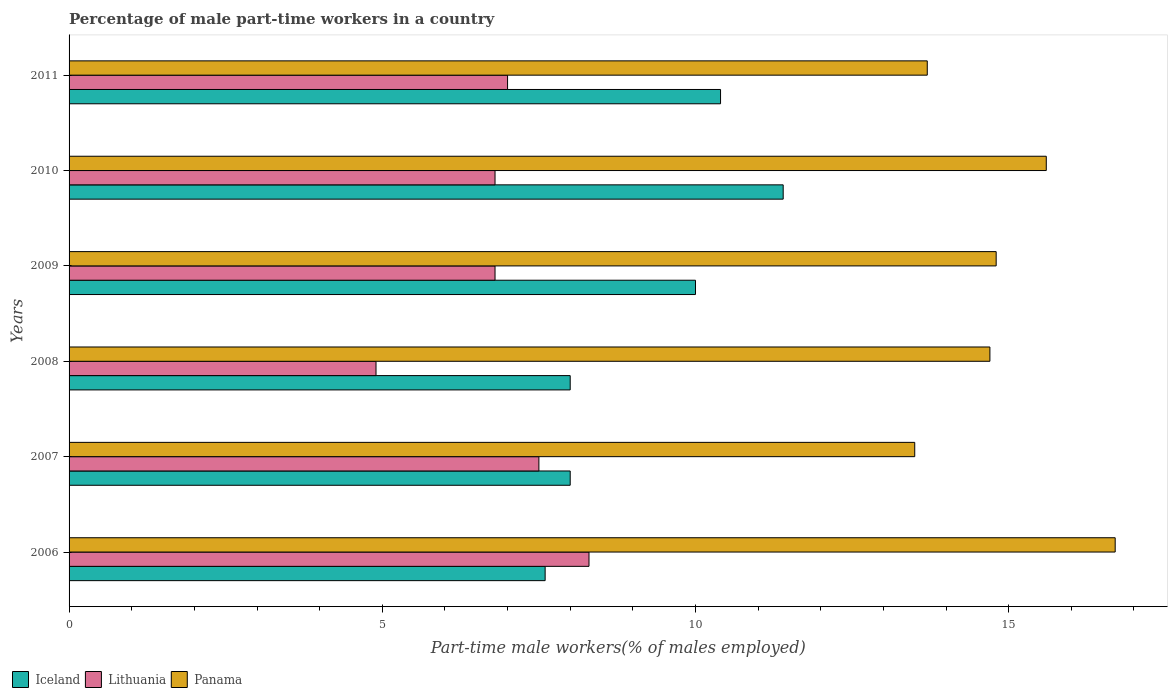How many different coloured bars are there?
Offer a terse response. 3. Are the number of bars on each tick of the Y-axis equal?
Provide a short and direct response. Yes. How many bars are there on the 1st tick from the bottom?
Offer a terse response. 3. What is the label of the 3rd group of bars from the top?
Provide a succinct answer. 2009. What is the percentage of male part-time workers in Iceland in 2006?
Your response must be concise. 7.6. Across all years, what is the maximum percentage of male part-time workers in Panama?
Make the answer very short. 16.7. Across all years, what is the minimum percentage of male part-time workers in Lithuania?
Offer a very short reply. 4.9. In which year was the percentage of male part-time workers in Iceland maximum?
Offer a terse response. 2010. What is the total percentage of male part-time workers in Lithuania in the graph?
Make the answer very short. 41.3. What is the difference between the percentage of male part-time workers in Lithuania in 2007 and that in 2008?
Provide a succinct answer. 2.6. What is the difference between the percentage of male part-time workers in Lithuania in 2006 and the percentage of male part-time workers in Panama in 2007?
Give a very brief answer. -5.2. What is the average percentage of male part-time workers in Lithuania per year?
Your response must be concise. 6.88. In the year 2010, what is the difference between the percentage of male part-time workers in Panama and percentage of male part-time workers in Lithuania?
Make the answer very short. 8.8. In how many years, is the percentage of male part-time workers in Panama greater than 6 %?
Ensure brevity in your answer.  6. What is the ratio of the percentage of male part-time workers in Iceland in 2006 to that in 2007?
Offer a terse response. 0.95. Is the difference between the percentage of male part-time workers in Panama in 2009 and 2011 greater than the difference between the percentage of male part-time workers in Lithuania in 2009 and 2011?
Your response must be concise. Yes. What is the difference between the highest and the lowest percentage of male part-time workers in Panama?
Ensure brevity in your answer.  3.2. In how many years, is the percentage of male part-time workers in Lithuania greater than the average percentage of male part-time workers in Lithuania taken over all years?
Provide a short and direct response. 3. What does the 3rd bar from the top in 2009 represents?
Provide a short and direct response. Iceland. Is it the case that in every year, the sum of the percentage of male part-time workers in Panama and percentage of male part-time workers in Iceland is greater than the percentage of male part-time workers in Lithuania?
Keep it short and to the point. Yes. How many bars are there?
Offer a very short reply. 18. Are all the bars in the graph horizontal?
Keep it short and to the point. Yes. Does the graph contain grids?
Provide a short and direct response. No. How are the legend labels stacked?
Offer a terse response. Horizontal. What is the title of the graph?
Provide a succinct answer. Percentage of male part-time workers in a country. What is the label or title of the X-axis?
Give a very brief answer. Part-time male workers(% of males employed). What is the Part-time male workers(% of males employed) in Iceland in 2006?
Give a very brief answer. 7.6. What is the Part-time male workers(% of males employed) in Lithuania in 2006?
Ensure brevity in your answer.  8.3. What is the Part-time male workers(% of males employed) of Panama in 2006?
Provide a short and direct response. 16.7. What is the Part-time male workers(% of males employed) of Lithuania in 2008?
Offer a terse response. 4.9. What is the Part-time male workers(% of males employed) in Panama in 2008?
Give a very brief answer. 14.7. What is the Part-time male workers(% of males employed) in Iceland in 2009?
Make the answer very short. 10. What is the Part-time male workers(% of males employed) of Lithuania in 2009?
Your response must be concise. 6.8. What is the Part-time male workers(% of males employed) in Panama in 2009?
Ensure brevity in your answer.  14.8. What is the Part-time male workers(% of males employed) in Iceland in 2010?
Provide a short and direct response. 11.4. What is the Part-time male workers(% of males employed) in Lithuania in 2010?
Give a very brief answer. 6.8. What is the Part-time male workers(% of males employed) in Panama in 2010?
Provide a succinct answer. 15.6. What is the Part-time male workers(% of males employed) of Iceland in 2011?
Make the answer very short. 10.4. What is the Part-time male workers(% of males employed) of Panama in 2011?
Your answer should be very brief. 13.7. Across all years, what is the maximum Part-time male workers(% of males employed) in Iceland?
Your response must be concise. 11.4. Across all years, what is the maximum Part-time male workers(% of males employed) in Lithuania?
Your answer should be very brief. 8.3. Across all years, what is the maximum Part-time male workers(% of males employed) in Panama?
Keep it short and to the point. 16.7. Across all years, what is the minimum Part-time male workers(% of males employed) of Iceland?
Your response must be concise. 7.6. Across all years, what is the minimum Part-time male workers(% of males employed) in Lithuania?
Your answer should be very brief. 4.9. Across all years, what is the minimum Part-time male workers(% of males employed) of Panama?
Ensure brevity in your answer.  13.5. What is the total Part-time male workers(% of males employed) of Iceland in the graph?
Your answer should be very brief. 55.4. What is the total Part-time male workers(% of males employed) of Lithuania in the graph?
Your answer should be compact. 41.3. What is the total Part-time male workers(% of males employed) of Panama in the graph?
Ensure brevity in your answer.  89. What is the difference between the Part-time male workers(% of males employed) in Iceland in 2006 and that in 2007?
Make the answer very short. -0.4. What is the difference between the Part-time male workers(% of males employed) in Panama in 2006 and that in 2007?
Offer a terse response. 3.2. What is the difference between the Part-time male workers(% of males employed) of Iceland in 2006 and that in 2008?
Provide a succinct answer. -0.4. What is the difference between the Part-time male workers(% of males employed) in Lithuania in 2006 and that in 2008?
Give a very brief answer. 3.4. What is the difference between the Part-time male workers(% of males employed) in Panama in 2006 and that in 2008?
Provide a succinct answer. 2. What is the difference between the Part-time male workers(% of males employed) in Iceland in 2006 and that in 2009?
Your response must be concise. -2.4. What is the difference between the Part-time male workers(% of males employed) of Iceland in 2006 and that in 2010?
Your answer should be very brief. -3.8. What is the difference between the Part-time male workers(% of males employed) of Lithuania in 2006 and that in 2010?
Provide a succinct answer. 1.5. What is the difference between the Part-time male workers(% of males employed) in Lithuania in 2006 and that in 2011?
Make the answer very short. 1.3. What is the difference between the Part-time male workers(% of males employed) of Panama in 2006 and that in 2011?
Your answer should be compact. 3. What is the difference between the Part-time male workers(% of males employed) of Iceland in 2007 and that in 2008?
Provide a short and direct response. 0. What is the difference between the Part-time male workers(% of males employed) in Panama in 2007 and that in 2008?
Give a very brief answer. -1.2. What is the difference between the Part-time male workers(% of males employed) of Lithuania in 2007 and that in 2009?
Ensure brevity in your answer.  0.7. What is the difference between the Part-time male workers(% of males employed) of Iceland in 2007 and that in 2010?
Give a very brief answer. -3.4. What is the difference between the Part-time male workers(% of males employed) of Iceland in 2007 and that in 2011?
Your answer should be compact. -2.4. What is the difference between the Part-time male workers(% of males employed) of Lithuania in 2007 and that in 2011?
Offer a very short reply. 0.5. What is the difference between the Part-time male workers(% of males employed) of Lithuania in 2008 and that in 2011?
Give a very brief answer. -2.1. What is the difference between the Part-time male workers(% of males employed) of Iceland in 2009 and that in 2010?
Your response must be concise. -1.4. What is the difference between the Part-time male workers(% of males employed) of Panama in 2009 and that in 2010?
Provide a succinct answer. -0.8. What is the difference between the Part-time male workers(% of males employed) of Iceland in 2009 and that in 2011?
Keep it short and to the point. -0.4. What is the difference between the Part-time male workers(% of males employed) in Iceland in 2010 and that in 2011?
Make the answer very short. 1. What is the difference between the Part-time male workers(% of males employed) of Panama in 2010 and that in 2011?
Ensure brevity in your answer.  1.9. What is the difference between the Part-time male workers(% of males employed) of Iceland in 2006 and the Part-time male workers(% of males employed) of Panama in 2007?
Give a very brief answer. -5.9. What is the difference between the Part-time male workers(% of males employed) in Lithuania in 2006 and the Part-time male workers(% of males employed) in Panama in 2007?
Offer a terse response. -5.2. What is the difference between the Part-time male workers(% of males employed) of Iceland in 2006 and the Part-time male workers(% of males employed) of Panama in 2008?
Ensure brevity in your answer.  -7.1. What is the difference between the Part-time male workers(% of males employed) of Lithuania in 2006 and the Part-time male workers(% of males employed) of Panama in 2008?
Provide a succinct answer. -6.4. What is the difference between the Part-time male workers(% of males employed) in Iceland in 2006 and the Part-time male workers(% of males employed) in Panama in 2009?
Your answer should be compact. -7.2. What is the difference between the Part-time male workers(% of males employed) in Lithuania in 2006 and the Part-time male workers(% of males employed) in Panama in 2009?
Give a very brief answer. -6.5. What is the difference between the Part-time male workers(% of males employed) in Iceland in 2006 and the Part-time male workers(% of males employed) in Panama in 2010?
Give a very brief answer. -8. What is the difference between the Part-time male workers(% of males employed) of Iceland in 2007 and the Part-time male workers(% of males employed) of Lithuania in 2008?
Your answer should be very brief. 3.1. What is the difference between the Part-time male workers(% of males employed) of Lithuania in 2007 and the Part-time male workers(% of males employed) of Panama in 2008?
Make the answer very short. -7.2. What is the difference between the Part-time male workers(% of males employed) in Lithuania in 2007 and the Part-time male workers(% of males employed) in Panama in 2009?
Make the answer very short. -7.3. What is the difference between the Part-time male workers(% of males employed) of Iceland in 2007 and the Part-time male workers(% of males employed) of Lithuania in 2010?
Give a very brief answer. 1.2. What is the difference between the Part-time male workers(% of males employed) in Iceland in 2007 and the Part-time male workers(% of males employed) in Panama in 2010?
Offer a terse response. -7.6. What is the difference between the Part-time male workers(% of males employed) in Iceland in 2008 and the Part-time male workers(% of males employed) in Panama in 2009?
Give a very brief answer. -6.8. What is the difference between the Part-time male workers(% of males employed) in Iceland in 2008 and the Part-time male workers(% of males employed) in Lithuania in 2010?
Give a very brief answer. 1.2. What is the difference between the Part-time male workers(% of males employed) of Iceland in 2008 and the Part-time male workers(% of males employed) of Panama in 2010?
Provide a short and direct response. -7.6. What is the difference between the Part-time male workers(% of males employed) in Lithuania in 2008 and the Part-time male workers(% of males employed) in Panama in 2010?
Provide a short and direct response. -10.7. What is the difference between the Part-time male workers(% of males employed) in Iceland in 2008 and the Part-time male workers(% of males employed) in Lithuania in 2011?
Give a very brief answer. 1. What is the difference between the Part-time male workers(% of males employed) of Lithuania in 2008 and the Part-time male workers(% of males employed) of Panama in 2011?
Provide a succinct answer. -8.8. What is the difference between the Part-time male workers(% of males employed) in Iceland in 2009 and the Part-time male workers(% of males employed) in Lithuania in 2010?
Make the answer very short. 3.2. What is the difference between the Part-time male workers(% of males employed) in Iceland in 2009 and the Part-time male workers(% of males employed) in Panama in 2011?
Your response must be concise. -3.7. What is the average Part-time male workers(% of males employed) of Iceland per year?
Your answer should be very brief. 9.23. What is the average Part-time male workers(% of males employed) of Lithuania per year?
Make the answer very short. 6.88. What is the average Part-time male workers(% of males employed) of Panama per year?
Provide a succinct answer. 14.83. In the year 2006, what is the difference between the Part-time male workers(% of males employed) in Lithuania and Part-time male workers(% of males employed) in Panama?
Make the answer very short. -8.4. In the year 2007, what is the difference between the Part-time male workers(% of males employed) of Iceland and Part-time male workers(% of males employed) of Lithuania?
Your answer should be compact. 0.5. In the year 2007, what is the difference between the Part-time male workers(% of males employed) in Lithuania and Part-time male workers(% of males employed) in Panama?
Offer a very short reply. -6. In the year 2008, what is the difference between the Part-time male workers(% of males employed) in Iceland and Part-time male workers(% of males employed) in Panama?
Offer a terse response. -6.7. In the year 2008, what is the difference between the Part-time male workers(% of males employed) in Lithuania and Part-time male workers(% of males employed) in Panama?
Your answer should be very brief. -9.8. In the year 2009, what is the difference between the Part-time male workers(% of males employed) in Iceland and Part-time male workers(% of males employed) in Lithuania?
Your answer should be compact. 3.2. In the year 2009, what is the difference between the Part-time male workers(% of males employed) in Lithuania and Part-time male workers(% of males employed) in Panama?
Your answer should be compact. -8. In the year 2010, what is the difference between the Part-time male workers(% of males employed) in Iceland and Part-time male workers(% of males employed) in Lithuania?
Your answer should be compact. 4.6. In the year 2011, what is the difference between the Part-time male workers(% of males employed) of Iceland and Part-time male workers(% of males employed) of Lithuania?
Give a very brief answer. 3.4. In the year 2011, what is the difference between the Part-time male workers(% of males employed) in Iceland and Part-time male workers(% of males employed) in Panama?
Offer a very short reply. -3.3. What is the ratio of the Part-time male workers(% of males employed) of Lithuania in 2006 to that in 2007?
Your response must be concise. 1.11. What is the ratio of the Part-time male workers(% of males employed) in Panama in 2006 to that in 2007?
Give a very brief answer. 1.24. What is the ratio of the Part-time male workers(% of males employed) in Iceland in 2006 to that in 2008?
Ensure brevity in your answer.  0.95. What is the ratio of the Part-time male workers(% of males employed) in Lithuania in 2006 to that in 2008?
Provide a succinct answer. 1.69. What is the ratio of the Part-time male workers(% of males employed) in Panama in 2006 to that in 2008?
Give a very brief answer. 1.14. What is the ratio of the Part-time male workers(% of males employed) in Iceland in 2006 to that in 2009?
Give a very brief answer. 0.76. What is the ratio of the Part-time male workers(% of males employed) of Lithuania in 2006 to that in 2009?
Offer a terse response. 1.22. What is the ratio of the Part-time male workers(% of males employed) of Panama in 2006 to that in 2009?
Ensure brevity in your answer.  1.13. What is the ratio of the Part-time male workers(% of males employed) of Iceland in 2006 to that in 2010?
Ensure brevity in your answer.  0.67. What is the ratio of the Part-time male workers(% of males employed) in Lithuania in 2006 to that in 2010?
Make the answer very short. 1.22. What is the ratio of the Part-time male workers(% of males employed) of Panama in 2006 to that in 2010?
Your answer should be very brief. 1.07. What is the ratio of the Part-time male workers(% of males employed) in Iceland in 2006 to that in 2011?
Make the answer very short. 0.73. What is the ratio of the Part-time male workers(% of males employed) in Lithuania in 2006 to that in 2011?
Give a very brief answer. 1.19. What is the ratio of the Part-time male workers(% of males employed) in Panama in 2006 to that in 2011?
Your answer should be very brief. 1.22. What is the ratio of the Part-time male workers(% of males employed) in Iceland in 2007 to that in 2008?
Your answer should be very brief. 1. What is the ratio of the Part-time male workers(% of males employed) of Lithuania in 2007 to that in 2008?
Ensure brevity in your answer.  1.53. What is the ratio of the Part-time male workers(% of males employed) of Panama in 2007 to that in 2008?
Offer a very short reply. 0.92. What is the ratio of the Part-time male workers(% of males employed) of Iceland in 2007 to that in 2009?
Offer a terse response. 0.8. What is the ratio of the Part-time male workers(% of males employed) in Lithuania in 2007 to that in 2009?
Your answer should be very brief. 1.1. What is the ratio of the Part-time male workers(% of males employed) of Panama in 2007 to that in 2009?
Your answer should be very brief. 0.91. What is the ratio of the Part-time male workers(% of males employed) of Iceland in 2007 to that in 2010?
Your response must be concise. 0.7. What is the ratio of the Part-time male workers(% of males employed) in Lithuania in 2007 to that in 2010?
Make the answer very short. 1.1. What is the ratio of the Part-time male workers(% of males employed) of Panama in 2007 to that in 2010?
Offer a terse response. 0.87. What is the ratio of the Part-time male workers(% of males employed) in Iceland in 2007 to that in 2011?
Ensure brevity in your answer.  0.77. What is the ratio of the Part-time male workers(% of males employed) in Lithuania in 2007 to that in 2011?
Keep it short and to the point. 1.07. What is the ratio of the Part-time male workers(% of males employed) in Panama in 2007 to that in 2011?
Make the answer very short. 0.99. What is the ratio of the Part-time male workers(% of males employed) in Lithuania in 2008 to that in 2009?
Your answer should be compact. 0.72. What is the ratio of the Part-time male workers(% of males employed) of Panama in 2008 to that in 2009?
Provide a succinct answer. 0.99. What is the ratio of the Part-time male workers(% of males employed) of Iceland in 2008 to that in 2010?
Offer a very short reply. 0.7. What is the ratio of the Part-time male workers(% of males employed) in Lithuania in 2008 to that in 2010?
Offer a very short reply. 0.72. What is the ratio of the Part-time male workers(% of males employed) in Panama in 2008 to that in 2010?
Ensure brevity in your answer.  0.94. What is the ratio of the Part-time male workers(% of males employed) of Iceland in 2008 to that in 2011?
Your answer should be compact. 0.77. What is the ratio of the Part-time male workers(% of males employed) of Panama in 2008 to that in 2011?
Your response must be concise. 1.07. What is the ratio of the Part-time male workers(% of males employed) in Iceland in 2009 to that in 2010?
Your answer should be very brief. 0.88. What is the ratio of the Part-time male workers(% of males employed) of Lithuania in 2009 to that in 2010?
Your response must be concise. 1. What is the ratio of the Part-time male workers(% of males employed) in Panama in 2009 to that in 2010?
Keep it short and to the point. 0.95. What is the ratio of the Part-time male workers(% of males employed) in Iceland in 2009 to that in 2011?
Ensure brevity in your answer.  0.96. What is the ratio of the Part-time male workers(% of males employed) in Lithuania in 2009 to that in 2011?
Give a very brief answer. 0.97. What is the ratio of the Part-time male workers(% of males employed) of Panama in 2009 to that in 2011?
Keep it short and to the point. 1.08. What is the ratio of the Part-time male workers(% of males employed) of Iceland in 2010 to that in 2011?
Offer a terse response. 1.1. What is the ratio of the Part-time male workers(% of males employed) in Lithuania in 2010 to that in 2011?
Your response must be concise. 0.97. What is the ratio of the Part-time male workers(% of males employed) in Panama in 2010 to that in 2011?
Keep it short and to the point. 1.14. What is the difference between the highest and the second highest Part-time male workers(% of males employed) of Iceland?
Provide a short and direct response. 1. What is the difference between the highest and the second highest Part-time male workers(% of males employed) of Lithuania?
Offer a very short reply. 0.8. What is the difference between the highest and the second highest Part-time male workers(% of males employed) in Panama?
Make the answer very short. 1.1. What is the difference between the highest and the lowest Part-time male workers(% of males employed) in Iceland?
Provide a succinct answer. 3.8. 